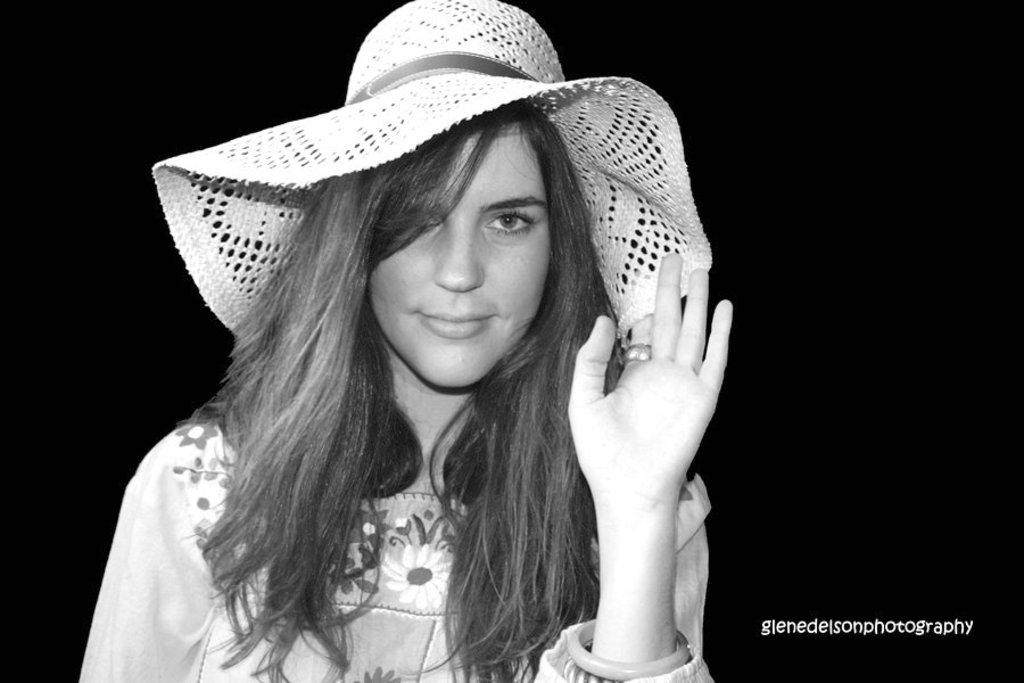Who is the main subject in the image? There is a woman in the image. What is the woman wearing on her head? The woman is wearing a hat. Can you describe the background of the image? The background of the image is dark. What is the color scheme of the image? The image appears to be black and white. What type of eggnog is the woman holding in the image? There is no eggnog present in the image; it features a woman wearing a hat with a dark background. Is the woman in the image a writer? There is no indication in the image that the woman is a writer. 